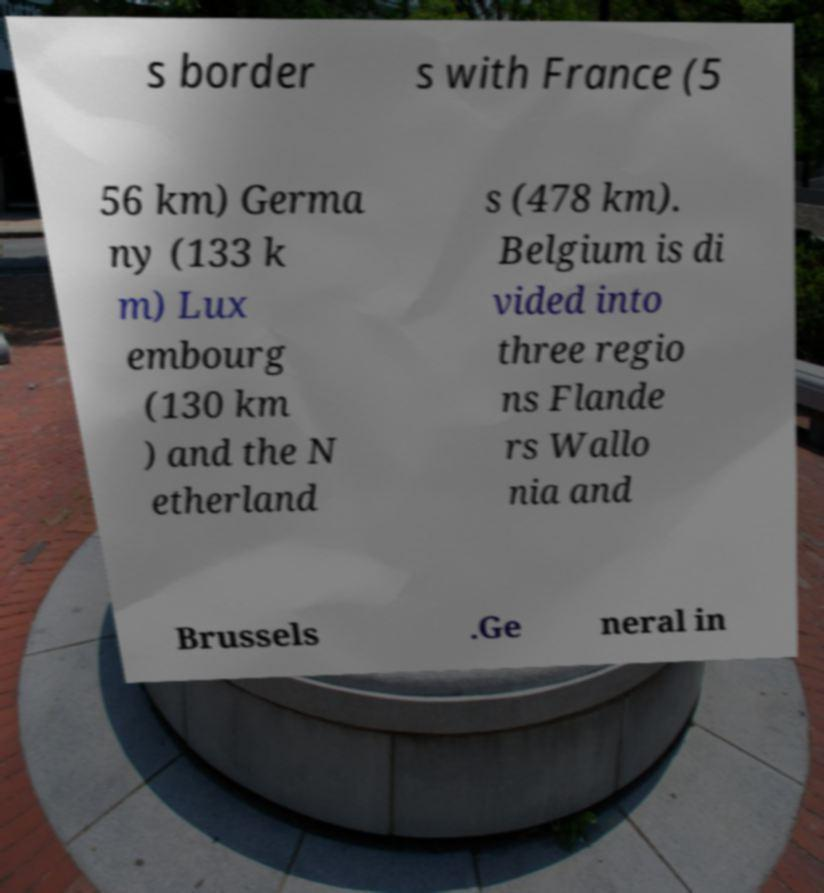Could you assist in decoding the text presented in this image and type it out clearly? s border s with France (5 56 km) Germa ny (133 k m) Lux embourg (130 km ) and the N etherland s (478 km). Belgium is di vided into three regio ns Flande rs Wallo nia and Brussels .Ge neral in 